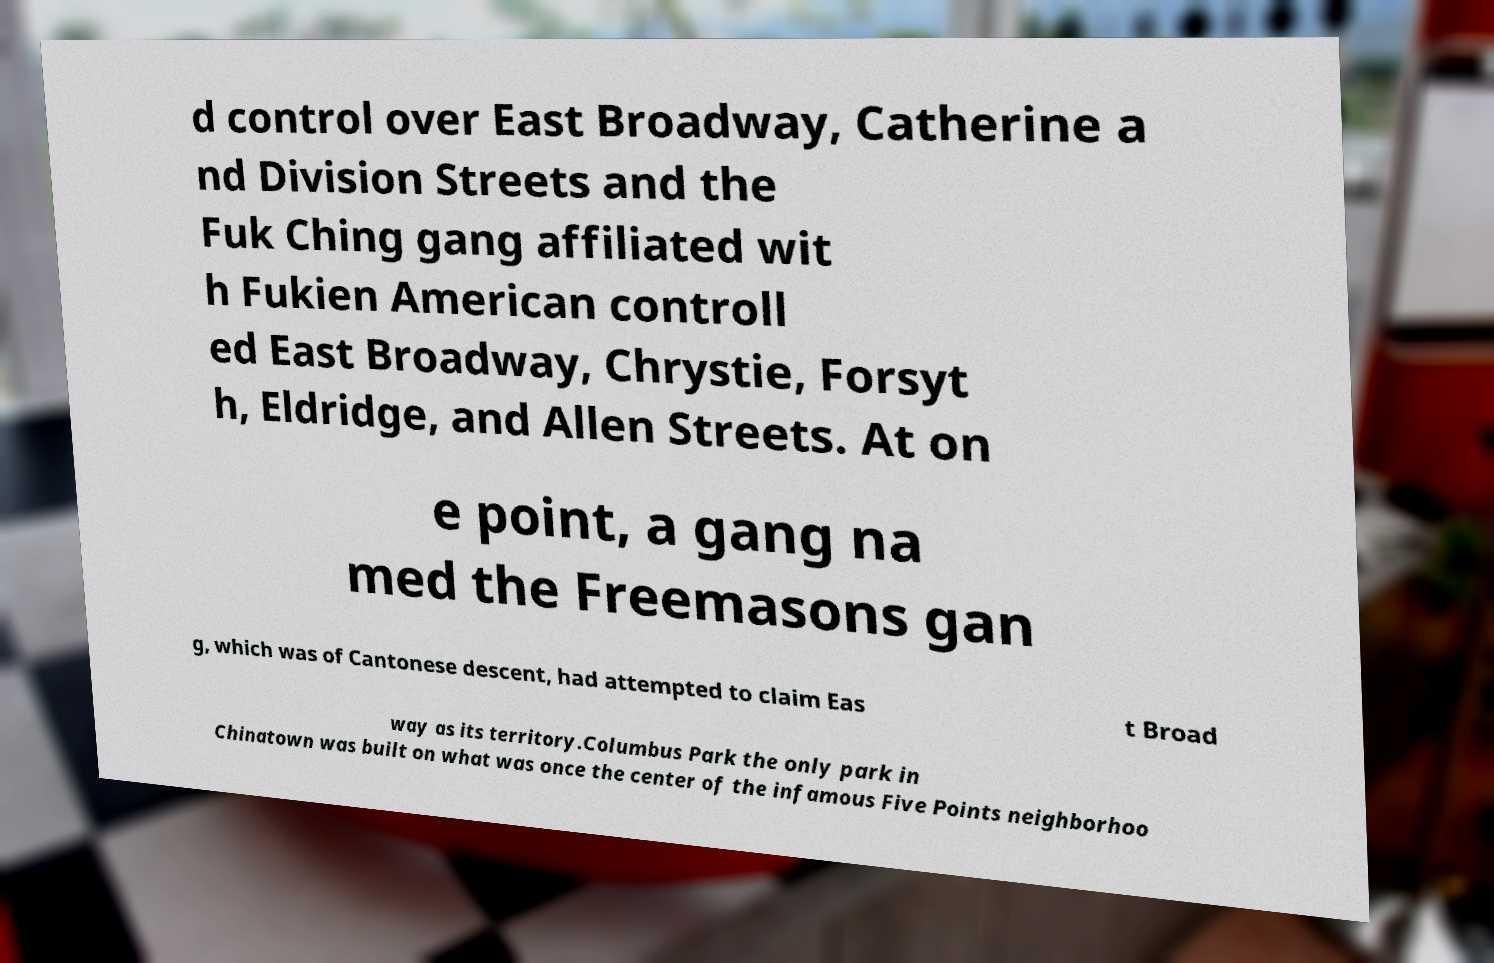Could you assist in decoding the text presented in this image and type it out clearly? d control over East Broadway, Catherine a nd Division Streets and the Fuk Ching gang affiliated wit h Fukien American controll ed East Broadway, Chrystie, Forsyt h, Eldridge, and Allen Streets. At on e point, a gang na med the Freemasons gan g, which was of Cantonese descent, had attempted to claim Eas t Broad way as its territory.Columbus Park the only park in Chinatown was built on what was once the center of the infamous Five Points neighborhoo 